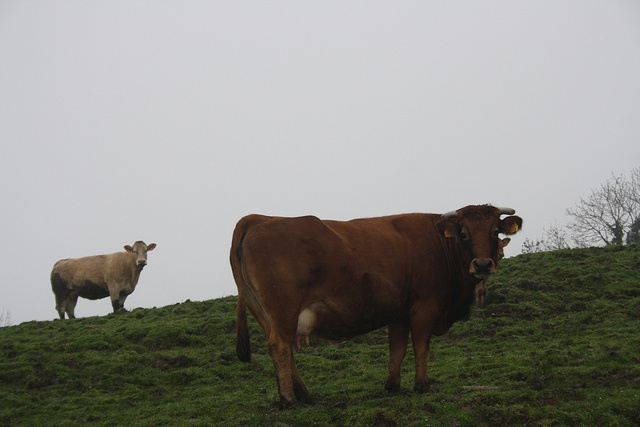Describe the objects in this image and their specific colors. I can see cow in lightgray, black, maroon, and darkgreen tones and cow in lightgray, black, and gray tones in this image. 